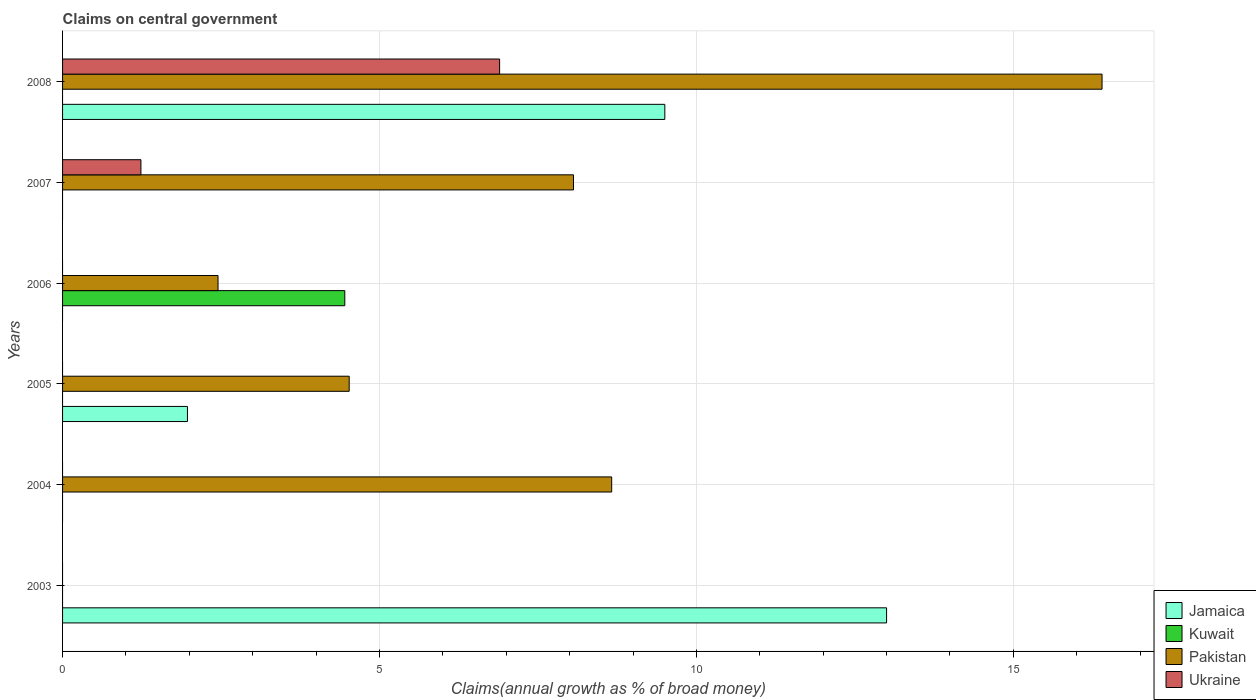Are the number of bars per tick equal to the number of legend labels?
Keep it short and to the point. No. In how many cases, is the number of bars for a given year not equal to the number of legend labels?
Your answer should be very brief. 6. What is the percentage of broad money claimed on centeral government in Pakistan in 2007?
Offer a terse response. 8.06. Across all years, what is the maximum percentage of broad money claimed on centeral government in Kuwait?
Keep it short and to the point. 4.45. What is the total percentage of broad money claimed on centeral government in Pakistan in the graph?
Provide a succinct answer. 40.1. What is the difference between the percentage of broad money claimed on centeral government in Jamaica in 2003 and that in 2008?
Your answer should be compact. 3.5. What is the difference between the percentage of broad money claimed on centeral government in Ukraine in 2006 and the percentage of broad money claimed on centeral government in Pakistan in 2003?
Give a very brief answer. 0. What is the average percentage of broad money claimed on centeral government in Jamaica per year?
Make the answer very short. 4.08. In the year 2005, what is the difference between the percentage of broad money claimed on centeral government in Pakistan and percentage of broad money claimed on centeral government in Jamaica?
Your response must be concise. 2.55. In how many years, is the percentage of broad money claimed on centeral government in Kuwait greater than 14 %?
Provide a succinct answer. 0. What is the difference between the highest and the second highest percentage of broad money claimed on centeral government in Jamaica?
Keep it short and to the point. 3.5. What is the difference between the highest and the lowest percentage of broad money claimed on centeral government in Kuwait?
Your answer should be compact. 4.45. In how many years, is the percentage of broad money claimed on centeral government in Jamaica greater than the average percentage of broad money claimed on centeral government in Jamaica taken over all years?
Make the answer very short. 2. Is it the case that in every year, the sum of the percentage of broad money claimed on centeral government in Jamaica and percentage of broad money claimed on centeral government in Ukraine is greater than the sum of percentage of broad money claimed on centeral government in Pakistan and percentage of broad money claimed on centeral government in Kuwait?
Keep it short and to the point. No. Is it the case that in every year, the sum of the percentage of broad money claimed on centeral government in Ukraine and percentage of broad money claimed on centeral government in Pakistan is greater than the percentage of broad money claimed on centeral government in Jamaica?
Make the answer very short. No. How many bars are there?
Provide a succinct answer. 11. How many years are there in the graph?
Provide a short and direct response. 6. What is the difference between two consecutive major ticks on the X-axis?
Your answer should be very brief. 5. Does the graph contain grids?
Provide a succinct answer. Yes. How many legend labels are there?
Provide a succinct answer. 4. What is the title of the graph?
Give a very brief answer. Claims on central government. Does "Macedonia" appear as one of the legend labels in the graph?
Provide a short and direct response. No. What is the label or title of the X-axis?
Make the answer very short. Claims(annual growth as % of broad money). What is the Claims(annual growth as % of broad money) in Jamaica in 2003?
Make the answer very short. 13. What is the Claims(annual growth as % of broad money) in Kuwait in 2003?
Provide a short and direct response. 0. What is the Claims(annual growth as % of broad money) of Pakistan in 2003?
Make the answer very short. 0. What is the Claims(annual growth as % of broad money) of Pakistan in 2004?
Give a very brief answer. 8.66. What is the Claims(annual growth as % of broad money) in Jamaica in 2005?
Offer a very short reply. 1.97. What is the Claims(annual growth as % of broad money) in Kuwait in 2005?
Ensure brevity in your answer.  0. What is the Claims(annual growth as % of broad money) of Pakistan in 2005?
Offer a terse response. 4.52. What is the Claims(annual growth as % of broad money) in Ukraine in 2005?
Your answer should be compact. 0. What is the Claims(annual growth as % of broad money) of Jamaica in 2006?
Provide a short and direct response. 0. What is the Claims(annual growth as % of broad money) in Kuwait in 2006?
Make the answer very short. 4.45. What is the Claims(annual growth as % of broad money) in Pakistan in 2006?
Give a very brief answer. 2.45. What is the Claims(annual growth as % of broad money) of Jamaica in 2007?
Offer a very short reply. 0. What is the Claims(annual growth as % of broad money) of Pakistan in 2007?
Give a very brief answer. 8.06. What is the Claims(annual growth as % of broad money) of Ukraine in 2007?
Provide a short and direct response. 1.24. What is the Claims(annual growth as % of broad money) in Jamaica in 2008?
Your answer should be compact. 9.5. What is the Claims(annual growth as % of broad money) of Pakistan in 2008?
Offer a very short reply. 16.4. What is the Claims(annual growth as % of broad money) in Ukraine in 2008?
Keep it short and to the point. 6.9. Across all years, what is the maximum Claims(annual growth as % of broad money) of Jamaica?
Your response must be concise. 13. Across all years, what is the maximum Claims(annual growth as % of broad money) in Kuwait?
Keep it short and to the point. 4.45. Across all years, what is the maximum Claims(annual growth as % of broad money) in Pakistan?
Make the answer very short. 16.4. Across all years, what is the maximum Claims(annual growth as % of broad money) of Ukraine?
Your answer should be very brief. 6.9. What is the total Claims(annual growth as % of broad money) in Jamaica in the graph?
Provide a succinct answer. 24.47. What is the total Claims(annual growth as % of broad money) in Kuwait in the graph?
Keep it short and to the point. 4.45. What is the total Claims(annual growth as % of broad money) of Pakistan in the graph?
Offer a terse response. 40.1. What is the total Claims(annual growth as % of broad money) in Ukraine in the graph?
Your answer should be very brief. 8.13. What is the difference between the Claims(annual growth as % of broad money) in Jamaica in 2003 and that in 2005?
Your response must be concise. 11.03. What is the difference between the Claims(annual growth as % of broad money) in Jamaica in 2003 and that in 2008?
Your answer should be compact. 3.5. What is the difference between the Claims(annual growth as % of broad money) of Pakistan in 2004 and that in 2005?
Your answer should be very brief. 4.14. What is the difference between the Claims(annual growth as % of broad money) in Pakistan in 2004 and that in 2006?
Give a very brief answer. 6.21. What is the difference between the Claims(annual growth as % of broad money) of Pakistan in 2004 and that in 2007?
Offer a terse response. 0.6. What is the difference between the Claims(annual growth as % of broad money) in Pakistan in 2004 and that in 2008?
Ensure brevity in your answer.  -7.74. What is the difference between the Claims(annual growth as % of broad money) in Pakistan in 2005 and that in 2006?
Provide a short and direct response. 2.07. What is the difference between the Claims(annual growth as % of broad money) in Pakistan in 2005 and that in 2007?
Your answer should be very brief. -3.54. What is the difference between the Claims(annual growth as % of broad money) in Jamaica in 2005 and that in 2008?
Ensure brevity in your answer.  -7.53. What is the difference between the Claims(annual growth as % of broad money) of Pakistan in 2005 and that in 2008?
Offer a terse response. -11.88. What is the difference between the Claims(annual growth as % of broad money) of Pakistan in 2006 and that in 2007?
Your answer should be compact. -5.61. What is the difference between the Claims(annual growth as % of broad money) in Pakistan in 2006 and that in 2008?
Provide a succinct answer. -13.95. What is the difference between the Claims(annual growth as % of broad money) of Pakistan in 2007 and that in 2008?
Offer a terse response. -8.34. What is the difference between the Claims(annual growth as % of broad money) of Ukraine in 2007 and that in 2008?
Make the answer very short. -5.66. What is the difference between the Claims(annual growth as % of broad money) of Jamaica in 2003 and the Claims(annual growth as % of broad money) of Pakistan in 2004?
Provide a succinct answer. 4.34. What is the difference between the Claims(annual growth as % of broad money) of Jamaica in 2003 and the Claims(annual growth as % of broad money) of Pakistan in 2005?
Make the answer very short. 8.48. What is the difference between the Claims(annual growth as % of broad money) in Jamaica in 2003 and the Claims(annual growth as % of broad money) in Kuwait in 2006?
Ensure brevity in your answer.  8.55. What is the difference between the Claims(annual growth as % of broad money) in Jamaica in 2003 and the Claims(annual growth as % of broad money) in Pakistan in 2006?
Offer a very short reply. 10.55. What is the difference between the Claims(annual growth as % of broad money) in Jamaica in 2003 and the Claims(annual growth as % of broad money) in Pakistan in 2007?
Provide a succinct answer. 4.94. What is the difference between the Claims(annual growth as % of broad money) of Jamaica in 2003 and the Claims(annual growth as % of broad money) of Ukraine in 2007?
Offer a terse response. 11.76. What is the difference between the Claims(annual growth as % of broad money) of Jamaica in 2003 and the Claims(annual growth as % of broad money) of Pakistan in 2008?
Your answer should be very brief. -3.4. What is the difference between the Claims(annual growth as % of broad money) in Jamaica in 2003 and the Claims(annual growth as % of broad money) in Ukraine in 2008?
Make the answer very short. 6.1. What is the difference between the Claims(annual growth as % of broad money) of Pakistan in 2004 and the Claims(annual growth as % of broad money) of Ukraine in 2007?
Make the answer very short. 7.43. What is the difference between the Claims(annual growth as % of broad money) of Pakistan in 2004 and the Claims(annual growth as % of broad money) of Ukraine in 2008?
Ensure brevity in your answer.  1.77. What is the difference between the Claims(annual growth as % of broad money) in Jamaica in 2005 and the Claims(annual growth as % of broad money) in Kuwait in 2006?
Offer a terse response. -2.48. What is the difference between the Claims(annual growth as % of broad money) in Jamaica in 2005 and the Claims(annual growth as % of broad money) in Pakistan in 2006?
Give a very brief answer. -0.48. What is the difference between the Claims(annual growth as % of broad money) in Jamaica in 2005 and the Claims(annual growth as % of broad money) in Pakistan in 2007?
Give a very brief answer. -6.09. What is the difference between the Claims(annual growth as % of broad money) in Jamaica in 2005 and the Claims(annual growth as % of broad money) in Ukraine in 2007?
Your answer should be very brief. 0.73. What is the difference between the Claims(annual growth as % of broad money) of Pakistan in 2005 and the Claims(annual growth as % of broad money) of Ukraine in 2007?
Your answer should be compact. 3.29. What is the difference between the Claims(annual growth as % of broad money) of Jamaica in 2005 and the Claims(annual growth as % of broad money) of Pakistan in 2008?
Offer a very short reply. -14.43. What is the difference between the Claims(annual growth as % of broad money) in Jamaica in 2005 and the Claims(annual growth as % of broad money) in Ukraine in 2008?
Give a very brief answer. -4.92. What is the difference between the Claims(annual growth as % of broad money) in Pakistan in 2005 and the Claims(annual growth as % of broad money) in Ukraine in 2008?
Offer a very short reply. -2.37. What is the difference between the Claims(annual growth as % of broad money) in Kuwait in 2006 and the Claims(annual growth as % of broad money) in Pakistan in 2007?
Offer a very short reply. -3.61. What is the difference between the Claims(annual growth as % of broad money) of Kuwait in 2006 and the Claims(annual growth as % of broad money) of Ukraine in 2007?
Offer a very short reply. 3.22. What is the difference between the Claims(annual growth as % of broad money) in Pakistan in 2006 and the Claims(annual growth as % of broad money) in Ukraine in 2007?
Your answer should be compact. 1.22. What is the difference between the Claims(annual growth as % of broad money) of Kuwait in 2006 and the Claims(annual growth as % of broad money) of Pakistan in 2008?
Provide a succinct answer. -11.95. What is the difference between the Claims(annual growth as % of broad money) in Kuwait in 2006 and the Claims(annual growth as % of broad money) in Ukraine in 2008?
Offer a very short reply. -2.44. What is the difference between the Claims(annual growth as % of broad money) in Pakistan in 2006 and the Claims(annual growth as % of broad money) in Ukraine in 2008?
Your answer should be very brief. -4.44. What is the difference between the Claims(annual growth as % of broad money) in Pakistan in 2007 and the Claims(annual growth as % of broad money) in Ukraine in 2008?
Provide a succinct answer. 1.17. What is the average Claims(annual growth as % of broad money) in Jamaica per year?
Ensure brevity in your answer.  4.08. What is the average Claims(annual growth as % of broad money) in Kuwait per year?
Your answer should be very brief. 0.74. What is the average Claims(annual growth as % of broad money) in Pakistan per year?
Provide a short and direct response. 6.68. What is the average Claims(annual growth as % of broad money) of Ukraine per year?
Your answer should be compact. 1.36. In the year 2005, what is the difference between the Claims(annual growth as % of broad money) in Jamaica and Claims(annual growth as % of broad money) in Pakistan?
Give a very brief answer. -2.55. In the year 2007, what is the difference between the Claims(annual growth as % of broad money) in Pakistan and Claims(annual growth as % of broad money) in Ukraine?
Ensure brevity in your answer.  6.82. In the year 2008, what is the difference between the Claims(annual growth as % of broad money) in Jamaica and Claims(annual growth as % of broad money) in Pakistan?
Provide a succinct answer. -6.9. In the year 2008, what is the difference between the Claims(annual growth as % of broad money) in Jamaica and Claims(annual growth as % of broad money) in Ukraine?
Your response must be concise. 2.61. In the year 2008, what is the difference between the Claims(annual growth as % of broad money) in Pakistan and Claims(annual growth as % of broad money) in Ukraine?
Your answer should be very brief. 9.5. What is the ratio of the Claims(annual growth as % of broad money) in Jamaica in 2003 to that in 2005?
Offer a very short reply. 6.6. What is the ratio of the Claims(annual growth as % of broad money) in Jamaica in 2003 to that in 2008?
Make the answer very short. 1.37. What is the ratio of the Claims(annual growth as % of broad money) of Pakistan in 2004 to that in 2005?
Offer a terse response. 1.92. What is the ratio of the Claims(annual growth as % of broad money) of Pakistan in 2004 to that in 2006?
Provide a succinct answer. 3.53. What is the ratio of the Claims(annual growth as % of broad money) of Pakistan in 2004 to that in 2007?
Your answer should be compact. 1.07. What is the ratio of the Claims(annual growth as % of broad money) of Pakistan in 2004 to that in 2008?
Provide a short and direct response. 0.53. What is the ratio of the Claims(annual growth as % of broad money) of Pakistan in 2005 to that in 2006?
Make the answer very short. 1.84. What is the ratio of the Claims(annual growth as % of broad money) in Pakistan in 2005 to that in 2007?
Make the answer very short. 0.56. What is the ratio of the Claims(annual growth as % of broad money) in Jamaica in 2005 to that in 2008?
Provide a short and direct response. 0.21. What is the ratio of the Claims(annual growth as % of broad money) of Pakistan in 2005 to that in 2008?
Provide a succinct answer. 0.28. What is the ratio of the Claims(annual growth as % of broad money) of Pakistan in 2006 to that in 2007?
Offer a terse response. 0.3. What is the ratio of the Claims(annual growth as % of broad money) in Pakistan in 2006 to that in 2008?
Your answer should be very brief. 0.15. What is the ratio of the Claims(annual growth as % of broad money) of Pakistan in 2007 to that in 2008?
Provide a short and direct response. 0.49. What is the ratio of the Claims(annual growth as % of broad money) of Ukraine in 2007 to that in 2008?
Give a very brief answer. 0.18. What is the difference between the highest and the second highest Claims(annual growth as % of broad money) of Jamaica?
Make the answer very short. 3.5. What is the difference between the highest and the second highest Claims(annual growth as % of broad money) in Pakistan?
Give a very brief answer. 7.74. What is the difference between the highest and the lowest Claims(annual growth as % of broad money) of Jamaica?
Provide a succinct answer. 13. What is the difference between the highest and the lowest Claims(annual growth as % of broad money) of Kuwait?
Give a very brief answer. 4.45. What is the difference between the highest and the lowest Claims(annual growth as % of broad money) in Pakistan?
Offer a terse response. 16.4. What is the difference between the highest and the lowest Claims(annual growth as % of broad money) in Ukraine?
Your answer should be compact. 6.9. 